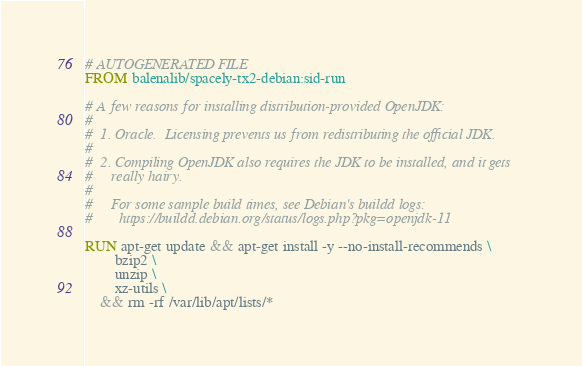Convert code to text. <code><loc_0><loc_0><loc_500><loc_500><_Dockerfile_># AUTOGENERATED FILE
FROM balenalib/spacely-tx2-debian:sid-run

# A few reasons for installing distribution-provided OpenJDK:
#
#  1. Oracle.  Licensing prevents us from redistributing the official JDK.
#
#  2. Compiling OpenJDK also requires the JDK to be installed, and it gets
#     really hairy.
#
#     For some sample build times, see Debian's buildd logs:
#       https://buildd.debian.org/status/logs.php?pkg=openjdk-11

RUN apt-get update && apt-get install -y --no-install-recommends \
		bzip2 \
		unzip \
		xz-utils \
	&& rm -rf /var/lib/apt/lists/*
</code> 